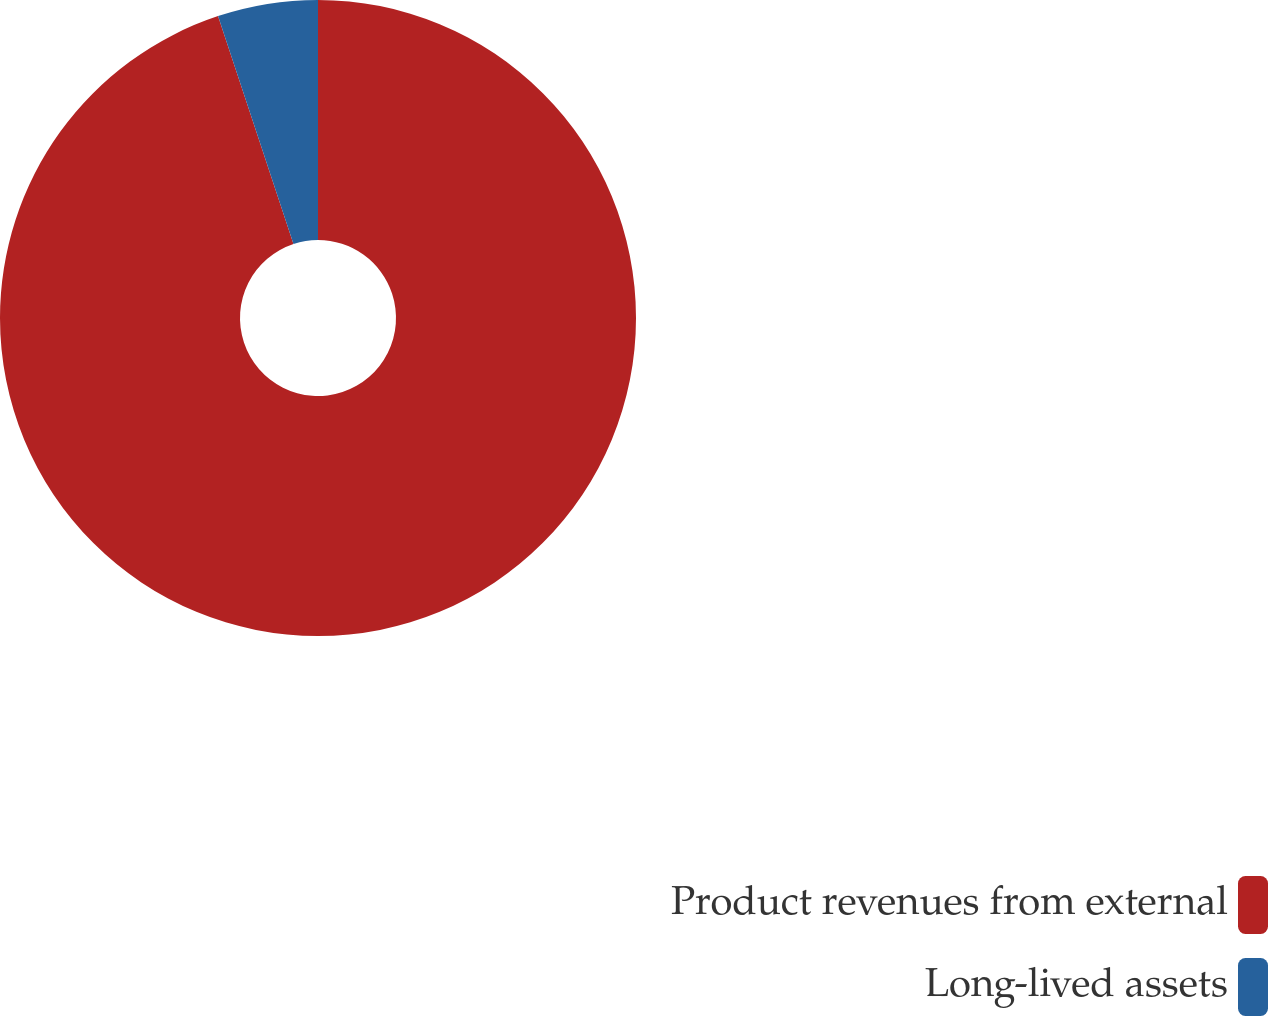Convert chart. <chart><loc_0><loc_0><loc_500><loc_500><pie_chart><fcel>Product revenues from external<fcel>Long-lived assets<nl><fcel>94.91%<fcel>5.09%<nl></chart> 